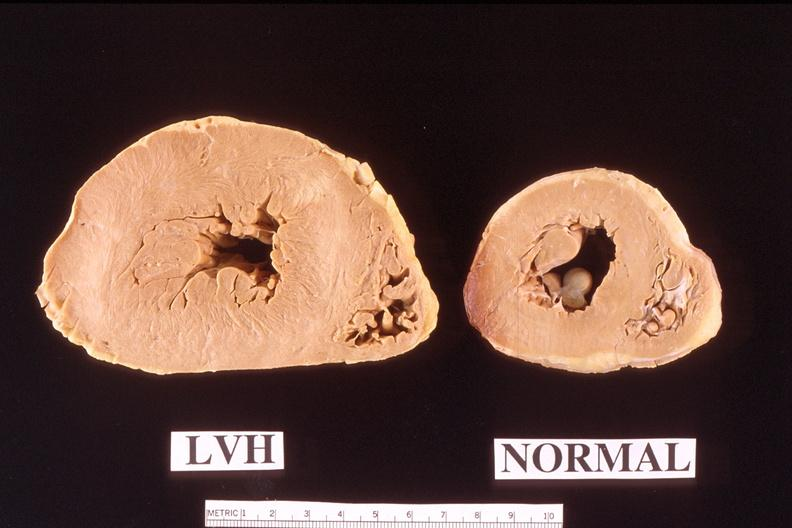how is heart left ventricular hypertrophy compared to heart?
Answer the question using a single word or phrase. Normal 